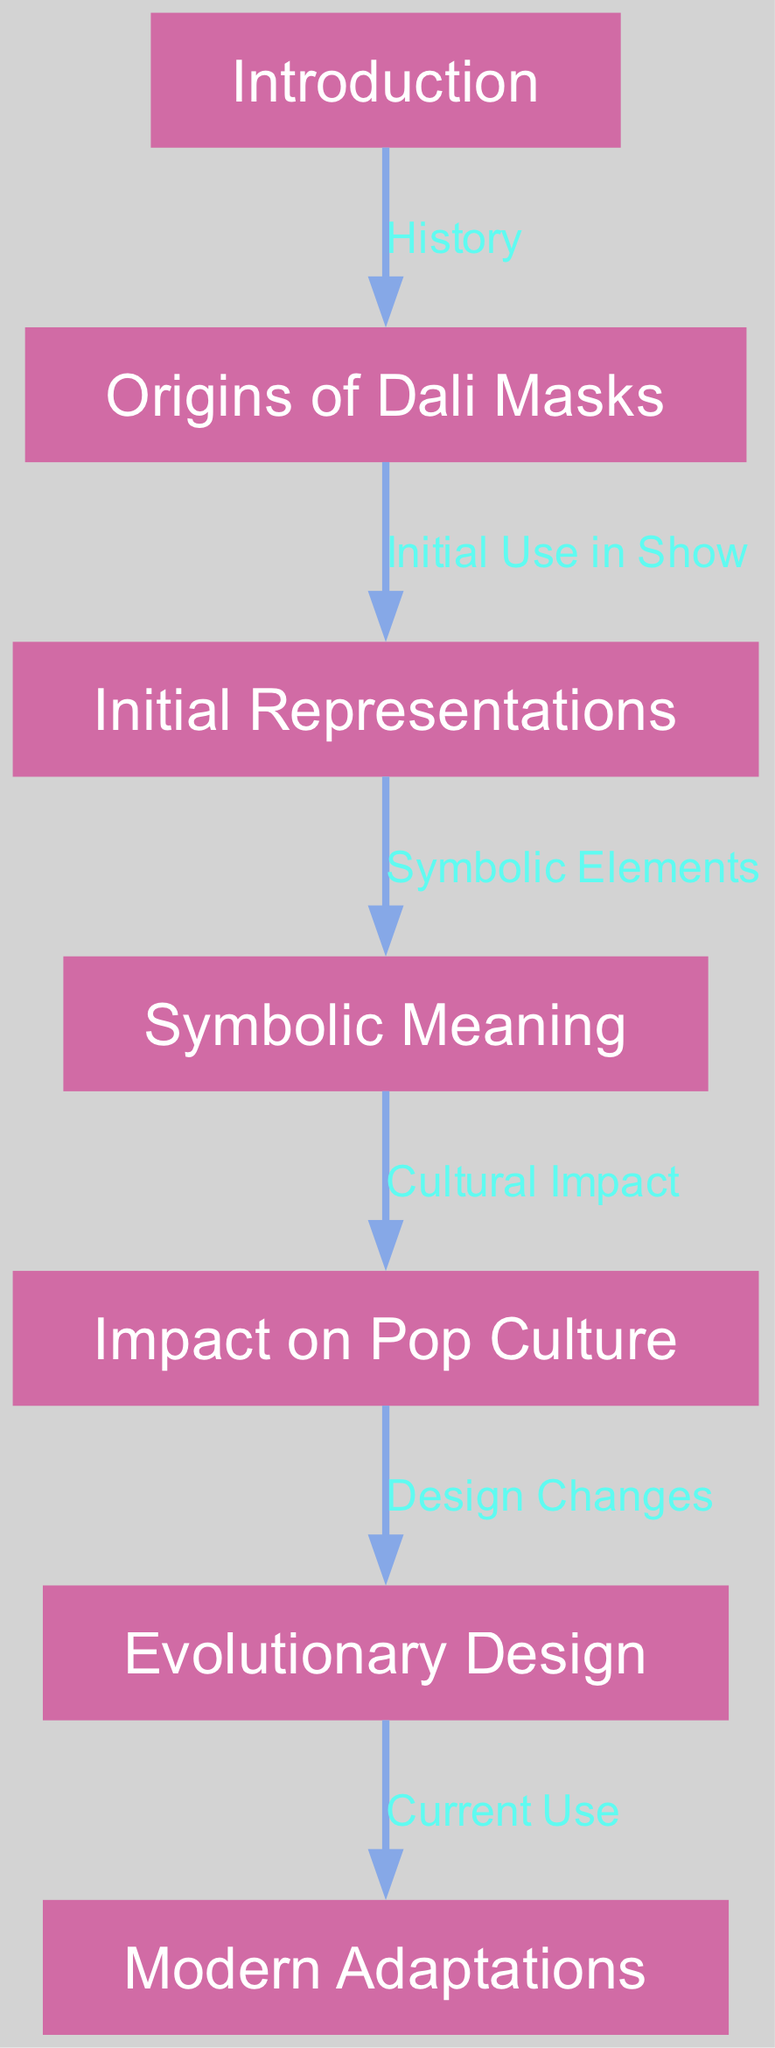What is the starting point of the diagram? The diagram begins with the node labeled "Introduction," which is the first element to the flow.
Answer: Introduction How many nodes are in the diagram? By counting the unique elements presented in the nodes section of the diagram, there are a total of 7 nodes listed.
Answer: 7 What is the relationship between "Origins of Dali Masks" and "Initial Representations"? The diagram shows a directed edge that indicates a flow from "Origins of Dali Masks" to "Initial Representations," labeled as "Initial Use in Show."
Answer: Initial Use in Show What does "Symbolic Meaning" lead to in the diagram? The "Symbolic Meaning" node has a directed edge that connects it to "Impact on Pop Culture," indicating the next step in the flow is this connection.
Answer: Impact on Pop Culture Which node follows "Evolutionary Design"? Following the node "Evolutionary Design," the diagram leads to the node labeled "Modern Adaptations," marking the next evolution stage.
Answer: Modern Adaptations What is the significance of the edge labeled "Cultural Impact"? The edge labeled "Cultural Impact" describes the significant influence that symbolism in "Symbolic Meaning" has on the broader public perceptions and representations, leading to changes in design.
Answer: Design Changes What do the Dali masks initially represent in the show? The flow indicates that the node "Initial Representations" contains information about their first use in the narrative of the show, emphasizing their purpose and symbolism.
Answer: Initial Use in Show Which aspects of the Dali masks are discussed in the evolution section? The "Evolutionary Design" node suggests discussions regarding changes to the design aspects of the masks as they continue to evolve over time, reflecting their ongoing cultural relevance.
Answer: Design Changes 